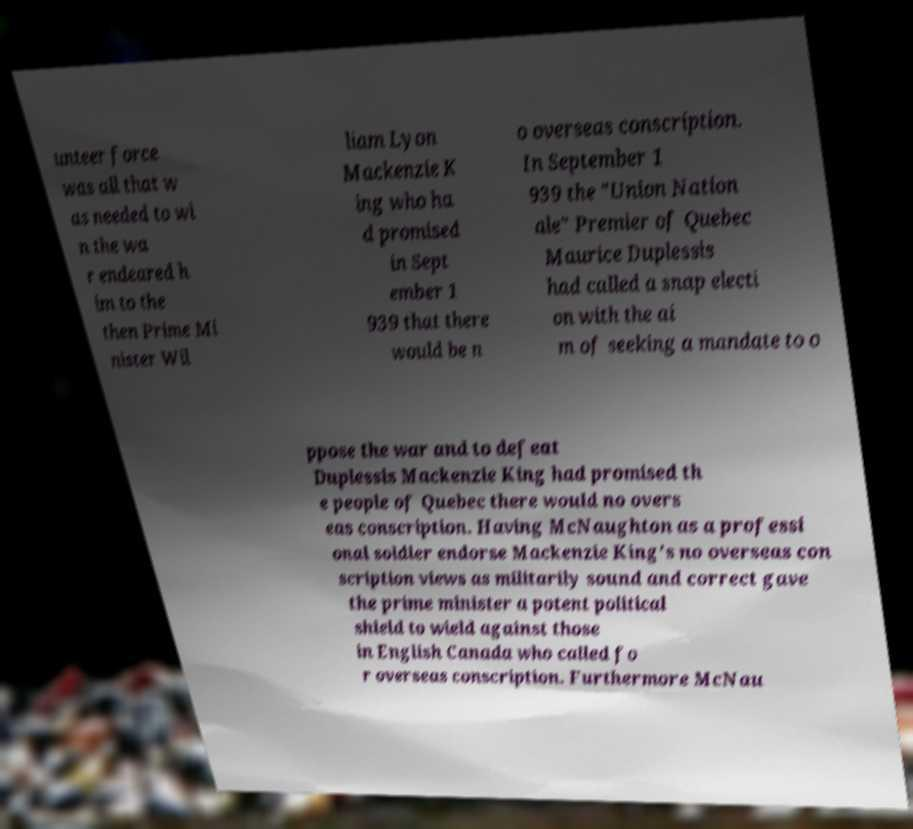For documentation purposes, I need the text within this image transcribed. Could you provide that? unteer force was all that w as needed to wi n the wa r endeared h im to the then Prime Mi nister Wil liam Lyon Mackenzie K ing who ha d promised in Sept ember 1 939 that there would be n o overseas conscription. In September 1 939 the "Union Nation ale" Premier of Quebec Maurice Duplessis had called a snap electi on with the ai m of seeking a mandate to o ppose the war and to defeat Duplessis Mackenzie King had promised th e people of Quebec there would no overs eas conscription. Having McNaughton as a professi onal soldier endorse Mackenzie King's no overseas con scription views as militarily sound and correct gave the prime minister a potent political shield to wield against those in English Canada who called fo r overseas conscription. Furthermore McNau 